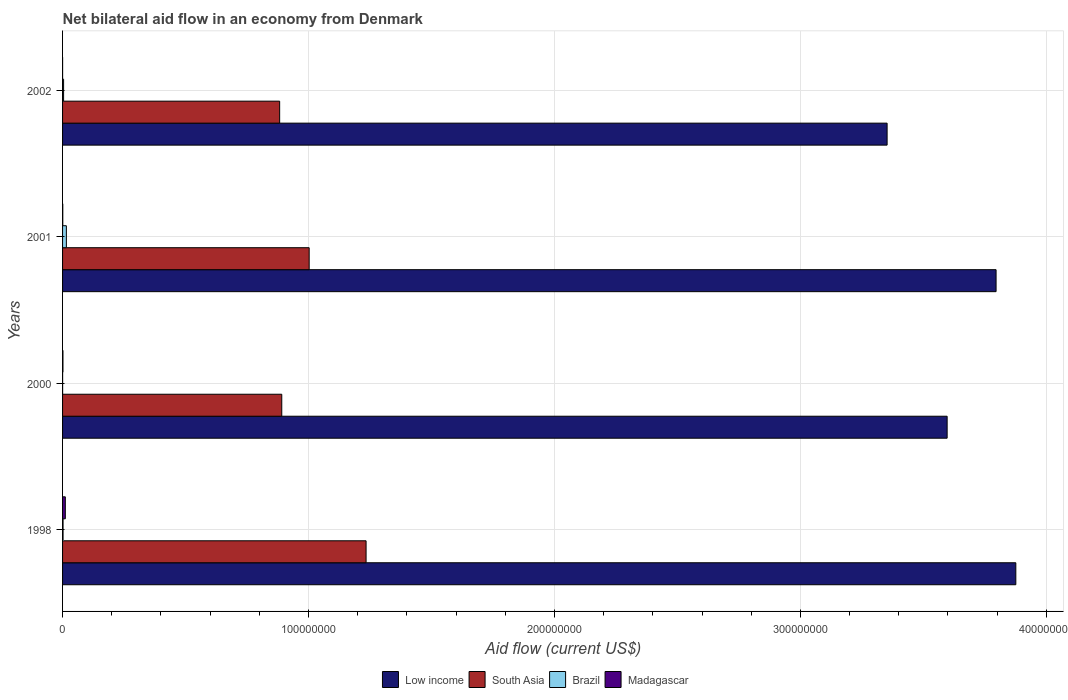How many different coloured bars are there?
Your answer should be very brief. 4. In how many cases, is the number of bars for a given year not equal to the number of legend labels?
Make the answer very short. 0. What is the net bilateral aid flow in Madagascar in 2000?
Your response must be concise. 1.60e+05. Across all years, what is the maximum net bilateral aid flow in South Asia?
Your answer should be very brief. 1.23e+08. Across all years, what is the minimum net bilateral aid flow in Madagascar?
Your response must be concise. 10000. In which year was the net bilateral aid flow in South Asia minimum?
Make the answer very short. 2002. What is the total net bilateral aid flow in Brazil in the graph?
Make the answer very short. 2.19e+06. What is the difference between the net bilateral aid flow in Madagascar in 2000 and the net bilateral aid flow in Low income in 2002?
Provide a short and direct response. -3.35e+08. What is the average net bilateral aid flow in Brazil per year?
Give a very brief answer. 5.48e+05. In the year 2002, what is the difference between the net bilateral aid flow in Low income and net bilateral aid flow in Brazil?
Ensure brevity in your answer.  3.35e+08. What is the ratio of the net bilateral aid flow in Low income in 1998 to that in 2001?
Your response must be concise. 1.02. Is the difference between the net bilateral aid flow in Low income in 2001 and 2002 greater than the difference between the net bilateral aid flow in Brazil in 2001 and 2002?
Give a very brief answer. Yes. What is the difference between the highest and the second highest net bilateral aid flow in Brazil?
Give a very brief answer. 1.13e+06. What is the difference between the highest and the lowest net bilateral aid flow in Brazil?
Keep it short and to the point. 1.53e+06. Is the sum of the net bilateral aid flow in Low income in 2000 and 2002 greater than the maximum net bilateral aid flow in South Asia across all years?
Give a very brief answer. Yes. Is it the case that in every year, the sum of the net bilateral aid flow in Brazil and net bilateral aid flow in Madagascar is greater than the sum of net bilateral aid flow in Low income and net bilateral aid flow in South Asia?
Keep it short and to the point. No. What does the 3rd bar from the top in 1998 represents?
Your answer should be very brief. South Asia. What does the 2nd bar from the bottom in 2002 represents?
Offer a terse response. South Asia. Are the values on the major ticks of X-axis written in scientific E-notation?
Provide a succinct answer. No. Does the graph contain any zero values?
Your answer should be compact. No. Does the graph contain grids?
Make the answer very short. Yes. Where does the legend appear in the graph?
Your response must be concise. Bottom center. How are the legend labels stacked?
Provide a short and direct response. Horizontal. What is the title of the graph?
Provide a short and direct response. Net bilateral aid flow in an economy from Denmark. Does "Bahamas" appear as one of the legend labels in the graph?
Give a very brief answer. No. What is the Aid flow (current US$) of Low income in 1998?
Keep it short and to the point. 3.88e+08. What is the Aid flow (current US$) in South Asia in 1998?
Provide a succinct answer. 1.23e+08. What is the Aid flow (current US$) in Brazil in 1998?
Your answer should be very brief. 2.00e+05. What is the Aid flow (current US$) of Madagascar in 1998?
Keep it short and to the point. 1.12e+06. What is the Aid flow (current US$) in Low income in 2000?
Provide a succinct answer. 3.60e+08. What is the Aid flow (current US$) in South Asia in 2000?
Make the answer very short. 8.91e+07. What is the Aid flow (current US$) in Brazil in 2000?
Your answer should be very brief. 2.00e+04. What is the Aid flow (current US$) in Madagascar in 2000?
Provide a succinct answer. 1.60e+05. What is the Aid flow (current US$) of Low income in 2001?
Offer a very short reply. 3.80e+08. What is the Aid flow (current US$) of South Asia in 2001?
Your answer should be very brief. 1.00e+08. What is the Aid flow (current US$) in Brazil in 2001?
Make the answer very short. 1.55e+06. What is the Aid flow (current US$) of Madagascar in 2001?
Offer a terse response. 9.00e+04. What is the Aid flow (current US$) of Low income in 2002?
Offer a terse response. 3.35e+08. What is the Aid flow (current US$) of South Asia in 2002?
Keep it short and to the point. 8.83e+07. Across all years, what is the maximum Aid flow (current US$) in Low income?
Provide a succinct answer. 3.88e+08. Across all years, what is the maximum Aid flow (current US$) of South Asia?
Your answer should be compact. 1.23e+08. Across all years, what is the maximum Aid flow (current US$) of Brazil?
Make the answer very short. 1.55e+06. Across all years, what is the maximum Aid flow (current US$) in Madagascar?
Your answer should be compact. 1.12e+06. Across all years, what is the minimum Aid flow (current US$) of Low income?
Give a very brief answer. 3.35e+08. Across all years, what is the minimum Aid flow (current US$) in South Asia?
Provide a short and direct response. 8.83e+07. What is the total Aid flow (current US$) of Low income in the graph?
Ensure brevity in your answer.  1.46e+09. What is the total Aid flow (current US$) of South Asia in the graph?
Your answer should be very brief. 4.01e+08. What is the total Aid flow (current US$) of Brazil in the graph?
Give a very brief answer. 2.19e+06. What is the total Aid flow (current US$) of Madagascar in the graph?
Make the answer very short. 1.38e+06. What is the difference between the Aid flow (current US$) in Low income in 1998 and that in 2000?
Your response must be concise. 2.79e+07. What is the difference between the Aid flow (current US$) of South Asia in 1998 and that in 2000?
Give a very brief answer. 3.43e+07. What is the difference between the Aid flow (current US$) of Brazil in 1998 and that in 2000?
Your response must be concise. 1.80e+05. What is the difference between the Aid flow (current US$) in Madagascar in 1998 and that in 2000?
Your answer should be very brief. 9.60e+05. What is the difference between the Aid flow (current US$) of Low income in 1998 and that in 2001?
Offer a very short reply. 8.03e+06. What is the difference between the Aid flow (current US$) in South Asia in 1998 and that in 2001?
Your answer should be very brief. 2.31e+07. What is the difference between the Aid flow (current US$) in Brazil in 1998 and that in 2001?
Offer a terse response. -1.35e+06. What is the difference between the Aid flow (current US$) of Madagascar in 1998 and that in 2001?
Make the answer very short. 1.03e+06. What is the difference between the Aid flow (current US$) of Low income in 1998 and that in 2002?
Your answer should be compact. 5.23e+07. What is the difference between the Aid flow (current US$) of South Asia in 1998 and that in 2002?
Give a very brief answer. 3.51e+07. What is the difference between the Aid flow (current US$) of Madagascar in 1998 and that in 2002?
Offer a terse response. 1.11e+06. What is the difference between the Aid flow (current US$) of Low income in 2000 and that in 2001?
Offer a terse response. -1.99e+07. What is the difference between the Aid flow (current US$) of South Asia in 2000 and that in 2001?
Make the answer very short. -1.11e+07. What is the difference between the Aid flow (current US$) in Brazil in 2000 and that in 2001?
Ensure brevity in your answer.  -1.53e+06. What is the difference between the Aid flow (current US$) of Madagascar in 2000 and that in 2001?
Offer a terse response. 7.00e+04. What is the difference between the Aid flow (current US$) of Low income in 2000 and that in 2002?
Ensure brevity in your answer.  2.44e+07. What is the difference between the Aid flow (current US$) of South Asia in 2000 and that in 2002?
Provide a succinct answer. 8.60e+05. What is the difference between the Aid flow (current US$) of Brazil in 2000 and that in 2002?
Offer a terse response. -4.00e+05. What is the difference between the Aid flow (current US$) in Low income in 2001 and that in 2002?
Ensure brevity in your answer.  4.43e+07. What is the difference between the Aid flow (current US$) of Brazil in 2001 and that in 2002?
Offer a terse response. 1.13e+06. What is the difference between the Aid flow (current US$) of Madagascar in 2001 and that in 2002?
Keep it short and to the point. 8.00e+04. What is the difference between the Aid flow (current US$) of Low income in 1998 and the Aid flow (current US$) of South Asia in 2000?
Offer a very short reply. 2.98e+08. What is the difference between the Aid flow (current US$) of Low income in 1998 and the Aid flow (current US$) of Brazil in 2000?
Your answer should be very brief. 3.88e+08. What is the difference between the Aid flow (current US$) in Low income in 1998 and the Aid flow (current US$) in Madagascar in 2000?
Make the answer very short. 3.87e+08. What is the difference between the Aid flow (current US$) of South Asia in 1998 and the Aid flow (current US$) of Brazil in 2000?
Provide a short and direct response. 1.23e+08. What is the difference between the Aid flow (current US$) in South Asia in 1998 and the Aid flow (current US$) in Madagascar in 2000?
Ensure brevity in your answer.  1.23e+08. What is the difference between the Aid flow (current US$) in Low income in 1998 and the Aid flow (current US$) in South Asia in 2001?
Your answer should be compact. 2.87e+08. What is the difference between the Aid flow (current US$) in Low income in 1998 and the Aid flow (current US$) in Brazil in 2001?
Your answer should be compact. 3.86e+08. What is the difference between the Aid flow (current US$) in Low income in 1998 and the Aid flow (current US$) in Madagascar in 2001?
Your response must be concise. 3.88e+08. What is the difference between the Aid flow (current US$) in South Asia in 1998 and the Aid flow (current US$) in Brazil in 2001?
Your answer should be very brief. 1.22e+08. What is the difference between the Aid flow (current US$) of South Asia in 1998 and the Aid flow (current US$) of Madagascar in 2001?
Offer a very short reply. 1.23e+08. What is the difference between the Aid flow (current US$) of Brazil in 1998 and the Aid flow (current US$) of Madagascar in 2001?
Make the answer very short. 1.10e+05. What is the difference between the Aid flow (current US$) in Low income in 1998 and the Aid flow (current US$) in South Asia in 2002?
Offer a very short reply. 2.99e+08. What is the difference between the Aid flow (current US$) in Low income in 1998 and the Aid flow (current US$) in Brazil in 2002?
Offer a very short reply. 3.87e+08. What is the difference between the Aid flow (current US$) in Low income in 1998 and the Aid flow (current US$) in Madagascar in 2002?
Offer a terse response. 3.88e+08. What is the difference between the Aid flow (current US$) of South Asia in 1998 and the Aid flow (current US$) of Brazil in 2002?
Your response must be concise. 1.23e+08. What is the difference between the Aid flow (current US$) in South Asia in 1998 and the Aid flow (current US$) in Madagascar in 2002?
Your answer should be very brief. 1.23e+08. What is the difference between the Aid flow (current US$) of Brazil in 1998 and the Aid flow (current US$) of Madagascar in 2002?
Your answer should be compact. 1.90e+05. What is the difference between the Aid flow (current US$) in Low income in 2000 and the Aid flow (current US$) in South Asia in 2001?
Offer a very short reply. 2.59e+08. What is the difference between the Aid flow (current US$) of Low income in 2000 and the Aid flow (current US$) of Brazil in 2001?
Make the answer very short. 3.58e+08. What is the difference between the Aid flow (current US$) in Low income in 2000 and the Aid flow (current US$) in Madagascar in 2001?
Offer a terse response. 3.60e+08. What is the difference between the Aid flow (current US$) of South Asia in 2000 and the Aid flow (current US$) of Brazil in 2001?
Your answer should be very brief. 8.76e+07. What is the difference between the Aid flow (current US$) of South Asia in 2000 and the Aid flow (current US$) of Madagascar in 2001?
Your response must be concise. 8.90e+07. What is the difference between the Aid flow (current US$) in Brazil in 2000 and the Aid flow (current US$) in Madagascar in 2001?
Make the answer very short. -7.00e+04. What is the difference between the Aid flow (current US$) in Low income in 2000 and the Aid flow (current US$) in South Asia in 2002?
Provide a succinct answer. 2.71e+08. What is the difference between the Aid flow (current US$) in Low income in 2000 and the Aid flow (current US$) in Brazil in 2002?
Provide a succinct answer. 3.59e+08. What is the difference between the Aid flow (current US$) in Low income in 2000 and the Aid flow (current US$) in Madagascar in 2002?
Your answer should be very brief. 3.60e+08. What is the difference between the Aid flow (current US$) of South Asia in 2000 and the Aid flow (current US$) of Brazil in 2002?
Keep it short and to the point. 8.87e+07. What is the difference between the Aid flow (current US$) of South Asia in 2000 and the Aid flow (current US$) of Madagascar in 2002?
Your answer should be compact. 8.91e+07. What is the difference between the Aid flow (current US$) in Brazil in 2000 and the Aid flow (current US$) in Madagascar in 2002?
Make the answer very short. 10000. What is the difference between the Aid flow (current US$) in Low income in 2001 and the Aid flow (current US$) in South Asia in 2002?
Offer a very short reply. 2.91e+08. What is the difference between the Aid flow (current US$) of Low income in 2001 and the Aid flow (current US$) of Brazil in 2002?
Give a very brief answer. 3.79e+08. What is the difference between the Aid flow (current US$) in Low income in 2001 and the Aid flow (current US$) in Madagascar in 2002?
Your answer should be compact. 3.80e+08. What is the difference between the Aid flow (current US$) in South Asia in 2001 and the Aid flow (current US$) in Brazil in 2002?
Your response must be concise. 9.98e+07. What is the difference between the Aid flow (current US$) in South Asia in 2001 and the Aid flow (current US$) in Madagascar in 2002?
Offer a very short reply. 1.00e+08. What is the difference between the Aid flow (current US$) of Brazil in 2001 and the Aid flow (current US$) of Madagascar in 2002?
Provide a succinct answer. 1.54e+06. What is the average Aid flow (current US$) of Low income per year?
Make the answer very short. 3.66e+08. What is the average Aid flow (current US$) in South Asia per year?
Provide a short and direct response. 1.00e+08. What is the average Aid flow (current US$) of Brazil per year?
Keep it short and to the point. 5.48e+05. What is the average Aid flow (current US$) in Madagascar per year?
Provide a succinct answer. 3.45e+05. In the year 1998, what is the difference between the Aid flow (current US$) of Low income and Aid flow (current US$) of South Asia?
Make the answer very short. 2.64e+08. In the year 1998, what is the difference between the Aid flow (current US$) in Low income and Aid flow (current US$) in Brazil?
Your answer should be compact. 3.87e+08. In the year 1998, what is the difference between the Aid flow (current US$) in Low income and Aid flow (current US$) in Madagascar?
Your answer should be compact. 3.86e+08. In the year 1998, what is the difference between the Aid flow (current US$) of South Asia and Aid flow (current US$) of Brazil?
Keep it short and to the point. 1.23e+08. In the year 1998, what is the difference between the Aid flow (current US$) of South Asia and Aid flow (current US$) of Madagascar?
Provide a succinct answer. 1.22e+08. In the year 1998, what is the difference between the Aid flow (current US$) in Brazil and Aid flow (current US$) in Madagascar?
Make the answer very short. -9.20e+05. In the year 2000, what is the difference between the Aid flow (current US$) of Low income and Aid flow (current US$) of South Asia?
Your answer should be compact. 2.71e+08. In the year 2000, what is the difference between the Aid flow (current US$) of Low income and Aid flow (current US$) of Brazil?
Keep it short and to the point. 3.60e+08. In the year 2000, what is the difference between the Aid flow (current US$) of Low income and Aid flow (current US$) of Madagascar?
Offer a very short reply. 3.60e+08. In the year 2000, what is the difference between the Aid flow (current US$) of South Asia and Aid flow (current US$) of Brazil?
Offer a very short reply. 8.91e+07. In the year 2000, what is the difference between the Aid flow (current US$) in South Asia and Aid flow (current US$) in Madagascar?
Your answer should be very brief. 8.90e+07. In the year 2000, what is the difference between the Aid flow (current US$) of Brazil and Aid flow (current US$) of Madagascar?
Keep it short and to the point. -1.40e+05. In the year 2001, what is the difference between the Aid flow (current US$) of Low income and Aid flow (current US$) of South Asia?
Your answer should be compact. 2.79e+08. In the year 2001, what is the difference between the Aid flow (current US$) in Low income and Aid flow (current US$) in Brazil?
Ensure brevity in your answer.  3.78e+08. In the year 2001, what is the difference between the Aid flow (current US$) of Low income and Aid flow (current US$) of Madagascar?
Give a very brief answer. 3.79e+08. In the year 2001, what is the difference between the Aid flow (current US$) in South Asia and Aid flow (current US$) in Brazil?
Give a very brief answer. 9.87e+07. In the year 2001, what is the difference between the Aid flow (current US$) of South Asia and Aid flow (current US$) of Madagascar?
Offer a very short reply. 1.00e+08. In the year 2001, what is the difference between the Aid flow (current US$) of Brazil and Aid flow (current US$) of Madagascar?
Your answer should be very brief. 1.46e+06. In the year 2002, what is the difference between the Aid flow (current US$) in Low income and Aid flow (current US$) in South Asia?
Provide a succinct answer. 2.47e+08. In the year 2002, what is the difference between the Aid flow (current US$) in Low income and Aid flow (current US$) in Brazil?
Keep it short and to the point. 3.35e+08. In the year 2002, what is the difference between the Aid flow (current US$) of Low income and Aid flow (current US$) of Madagascar?
Make the answer very short. 3.35e+08. In the year 2002, what is the difference between the Aid flow (current US$) in South Asia and Aid flow (current US$) in Brazil?
Make the answer very short. 8.78e+07. In the year 2002, what is the difference between the Aid flow (current US$) of South Asia and Aid flow (current US$) of Madagascar?
Your answer should be very brief. 8.83e+07. What is the ratio of the Aid flow (current US$) of Low income in 1998 to that in 2000?
Offer a very short reply. 1.08. What is the ratio of the Aid flow (current US$) in South Asia in 1998 to that in 2000?
Give a very brief answer. 1.38. What is the ratio of the Aid flow (current US$) of Brazil in 1998 to that in 2000?
Your answer should be compact. 10. What is the ratio of the Aid flow (current US$) in Madagascar in 1998 to that in 2000?
Provide a succinct answer. 7. What is the ratio of the Aid flow (current US$) in Low income in 1998 to that in 2001?
Your response must be concise. 1.02. What is the ratio of the Aid flow (current US$) in South Asia in 1998 to that in 2001?
Your response must be concise. 1.23. What is the ratio of the Aid flow (current US$) of Brazil in 1998 to that in 2001?
Your answer should be very brief. 0.13. What is the ratio of the Aid flow (current US$) in Madagascar in 1998 to that in 2001?
Provide a short and direct response. 12.44. What is the ratio of the Aid flow (current US$) in Low income in 1998 to that in 2002?
Provide a short and direct response. 1.16. What is the ratio of the Aid flow (current US$) of South Asia in 1998 to that in 2002?
Your response must be concise. 1.4. What is the ratio of the Aid flow (current US$) in Brazil in 1998 to that in 2002?
Provide a short and direct response. 0.48. What is the ratio of the Aid flow (current US$) in Madagascar in 1998 to that in 2002?
Provide a short and direct response. 112. What is the ratio of the Aid flow (current US$) of Low income in 2000 to that in 2001?
Provide a succinct answer. 0.95. What is the ratio of the Aid flow (current US$) in South Asia in 2000 to that in 2001?
Keep it short and to the point. 0.89. What is the ratio of the Aid flow (current US$) of Brazil in 2000 to that in 2001?
Keep it short and to the point. 0.01. What is the ratio of the Aid flow (current US$) of Madagascar in 2000 to that in 2001?
Provide a succinct answer. 1.78. What is the ratio of the Aid flow (current US$) in Low income in 2000 to that in 2002?
Keep it short and to the point. 1.07. What is the ratio of the Aid flow (current US$) in South Asia in 2000 to that in 2002?
Keep it short and to the point. 1.01. What is the ratio of the Aid flow (current US$) in Brazil in 2000 to that in 2002?
Your answer should be compact. 0.05. What is the ratio of the Aid flow (current US$) in Madagascar in 2000 to that in 2002?
Your answer should be very brief. 16. What is the ratio of the Aid flow (current US$) in Low income in 2001 to that in 2002?
Offer a very short reply. 1.13. What is the ratio of the Aid flow (current US$) in South Asia in 2001 to that in 2002?
Provide a short and direct response. 1.14. What is the ratio of the Aid flow (current US$) in Brazil in 2001 to that in 2002?
Ensure brevity in your answer.  3.69. What is the ratio of the Aid flow (current US$) in Madagascar in 2001 to that in 2002?
Give a very brief answer. 9. What is the difference between the highest and the second highest Aid flow (current US$) of Low income?
Your answer should be very brief. 8.03e+06. What is the difference between the highest and the second highest Aid flow (current US$) in South Asia?
Provide a short and direct response. 2.31e+07. What is the difference between the highest and the second highest Aid flow (current US$) of Brazil?
Offer a terse response. 1.13e+06. What is the difference between the highest and the second highest Aid flow (current US$) in Madagascar?
Keep it short and to the point. 9.60e+05. What is the difference between the highest and the lowest Aid flow (current US$) in Low income?
Make the answer very short. 5.23e+07. What is the difference between the highest and the lowest Aid flow (current US$) of South Asia?
Offer a very short reply. 3.51e+07. What is the difference between the highest and the lowest Aid flow (current US$) of Brazil?
Keep it short and to the point. 1.53e+06. What is the difference between the highest and the lowest Aid flow (current US$) of Madagascar?
Your response must be concise. 1.11e+06. 